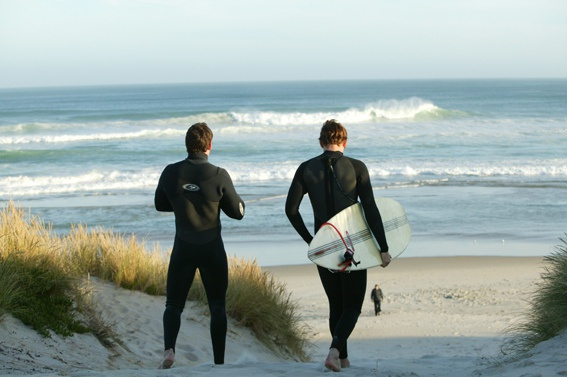Describe the objects in this image and their specific colors. I can see people in white, black, gray, and darkgreen tones, people in white, black, gray, and darkgray tones, and surfboard in white, darkgray, lightgray, beige, and gray tones in this image. 